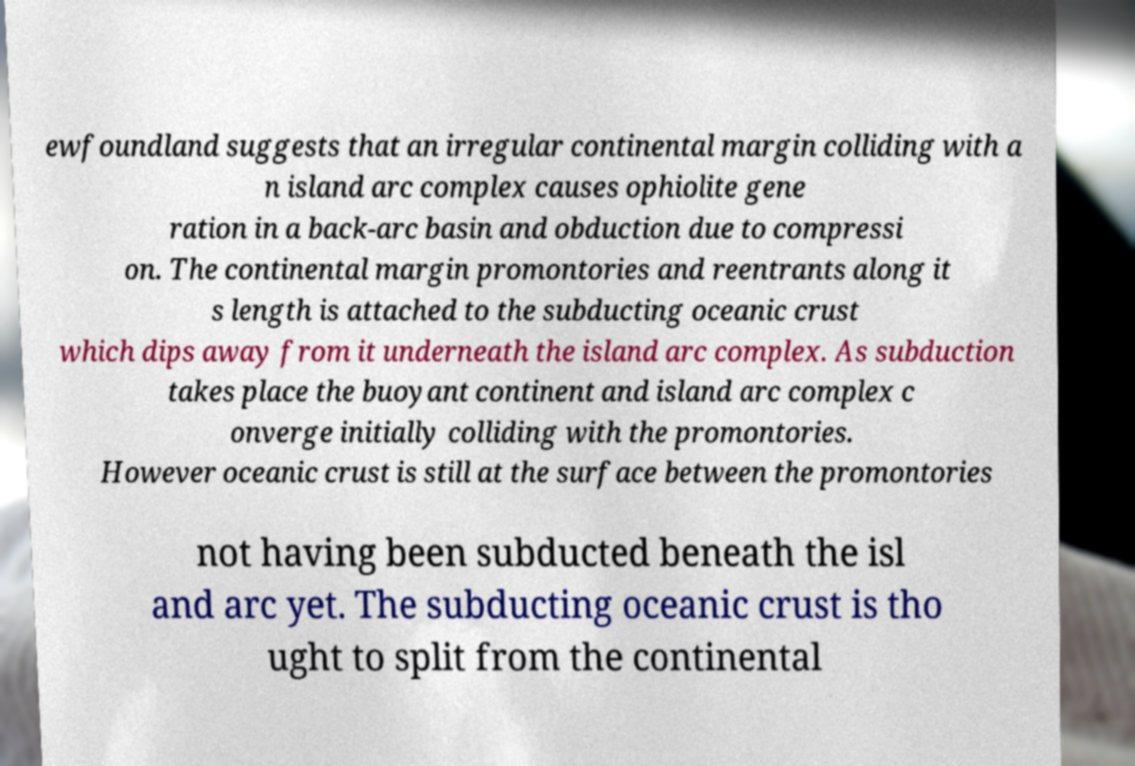Please identify and transcribe the text found in this image. ewfoundland suggests that an irregular continental margin colliding with a n island arc complex causes ophiolite gene ration in a back-arc basin and obduction due to compressi on. The continental margin promontories and reentrants along it s length is attached to the subducting oceanic crust which dips away from it underneath the island arc complex. As subduction takes place the buoyant continent and island arc complex c onverge initially colliding with the promontories. However oceanic crust is still at the surface between the promontories not having been subducted beneath the isl and arc yet. The subducting oceanic crust is tho ught to split from the continental 